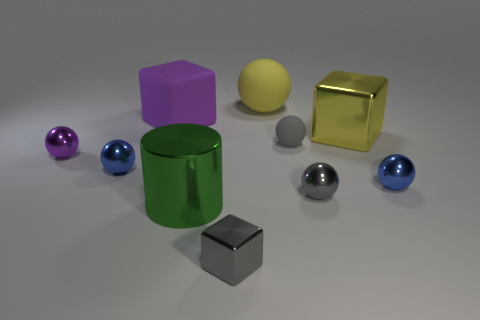Subtract all small cubes. How many cubes are left? 2 Subtract all green cylinders. How many gray balls are left? 2 Subtract all blue spheres. How many spheres are left? 4 Subtract all red balls. Subtract all purple cubes. How many balls are left? 6 Subtract all balls. How many objects are left? 4 Subtract 0 green balls. How many objects are left? 10 Subtract all purple matte blocks. Subtract all small purple shiny things. How many objects are left? 8 Add 1 large cubes. How many large cubes are left? 3 Add 9 big shiny balls. How many big shiny balls exist? 9 